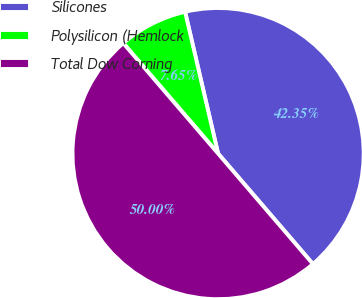Convert chart. <chart><loc_0><loc_0><loc_500><loc_500><pie_chart><fcel>Silicones<fcel>Polysilicon (Hemlock<fcel>Total Dow Corning<nl><fcel>42.35%<fcel>7.65%<fcel>50.0%<nl></chart> 